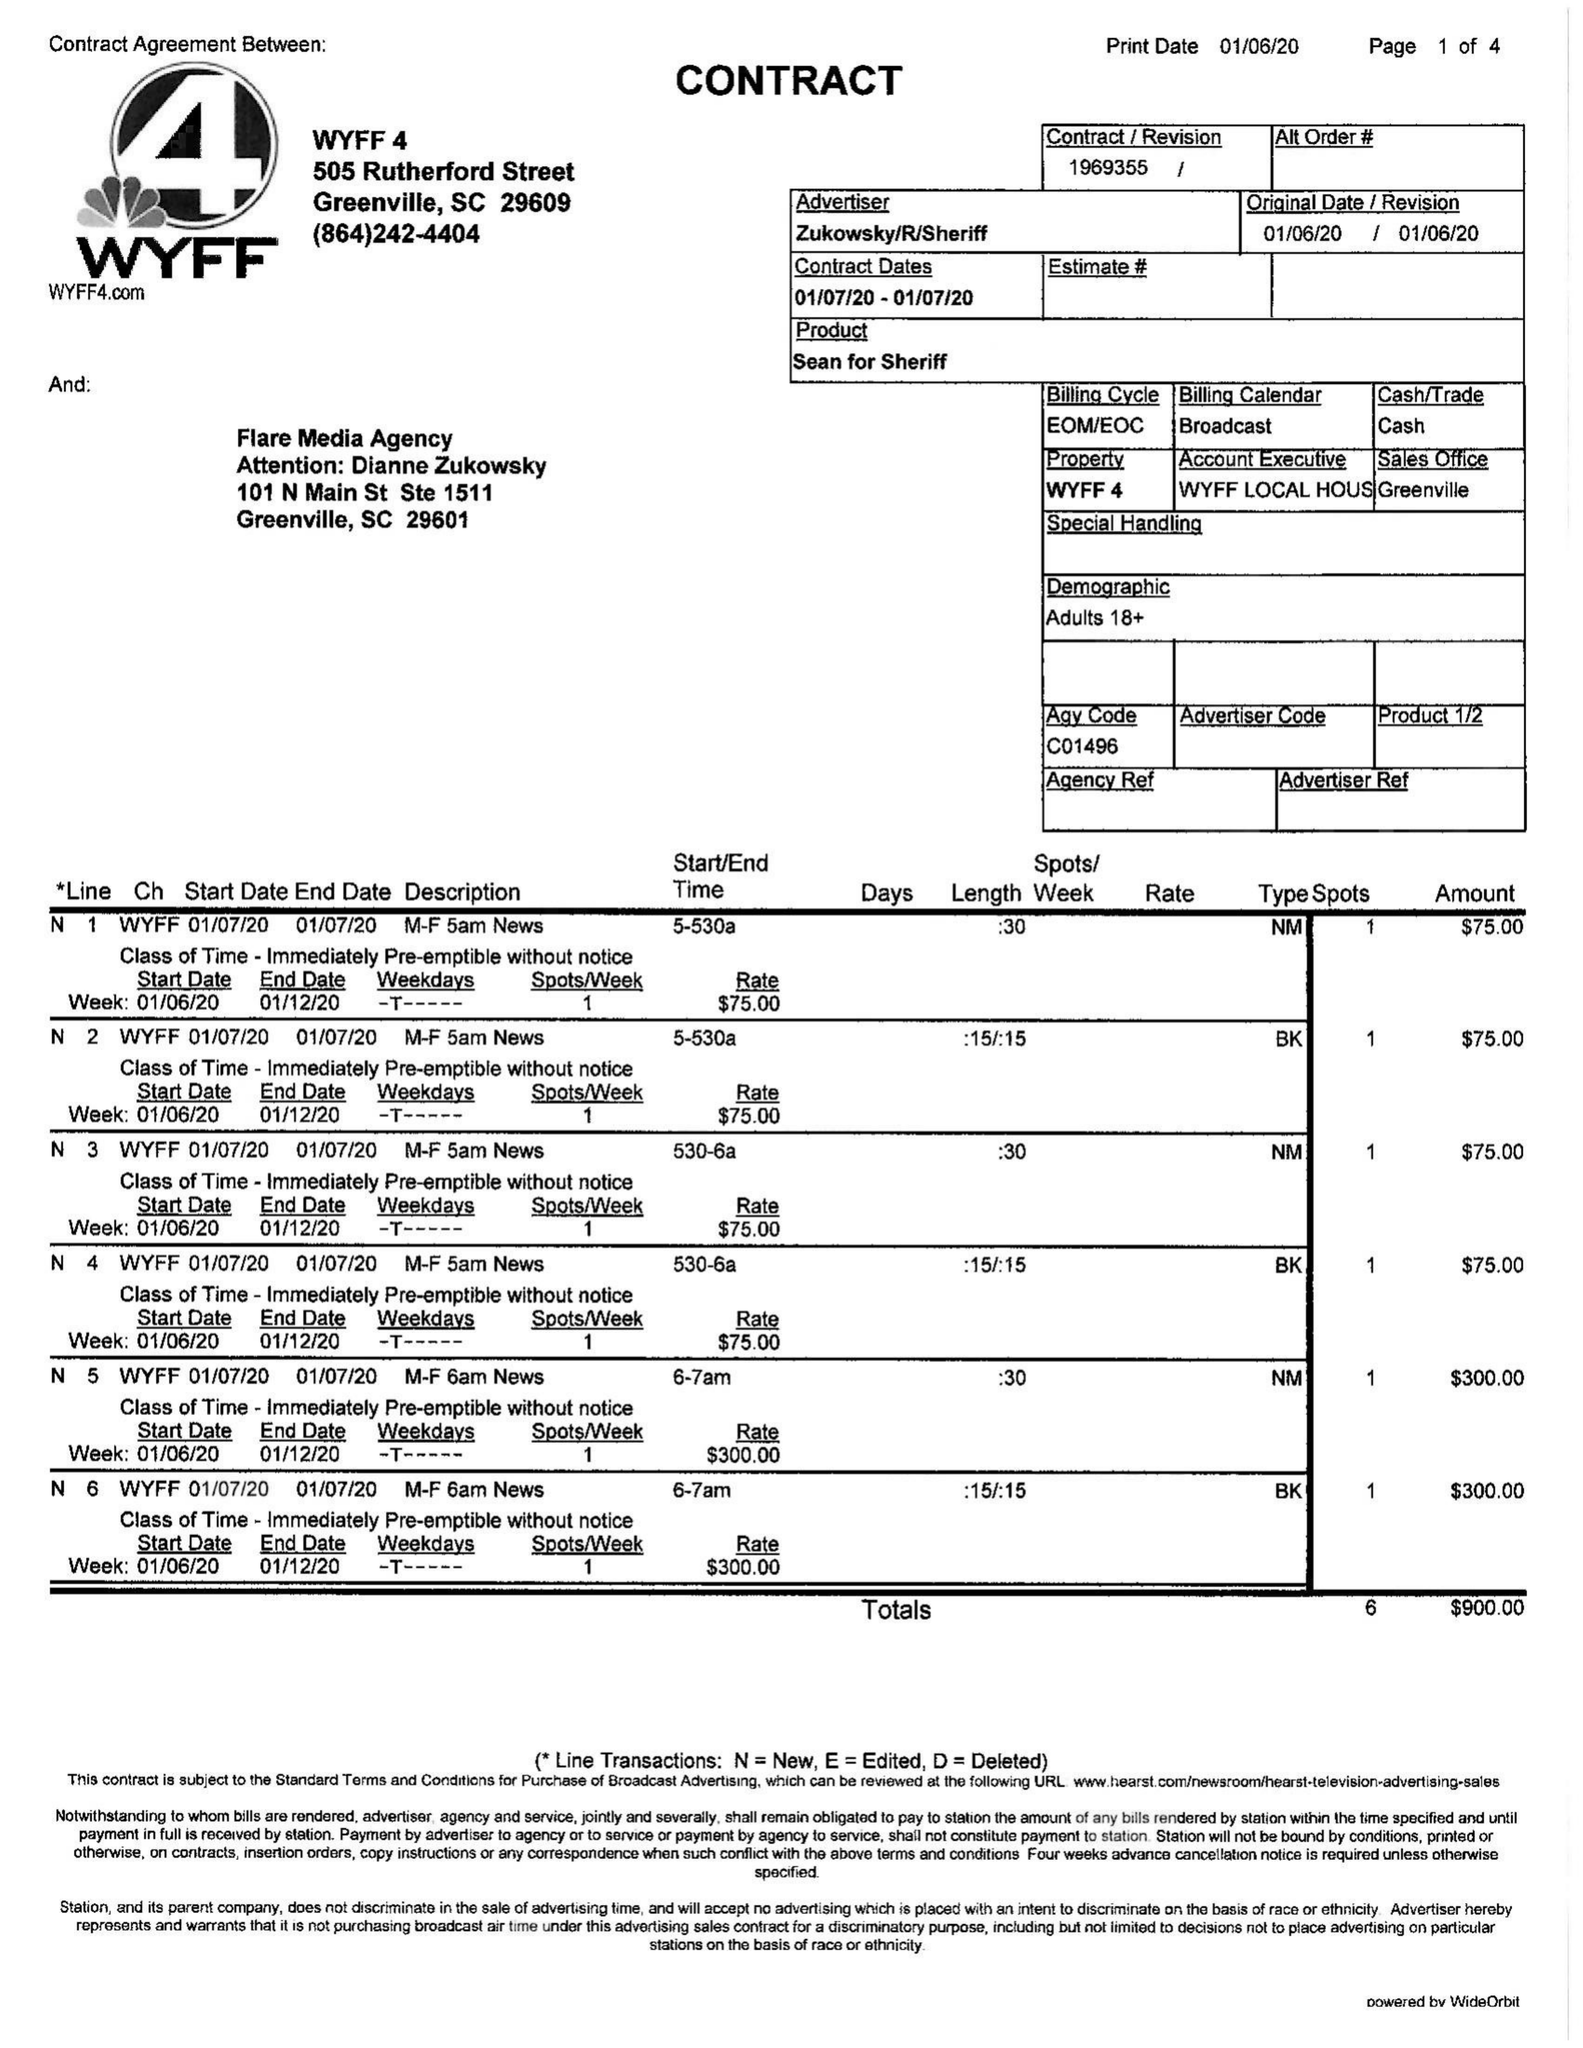What is the value for the gross_amount?
Answer the question using a single word or phrase. 900.00 